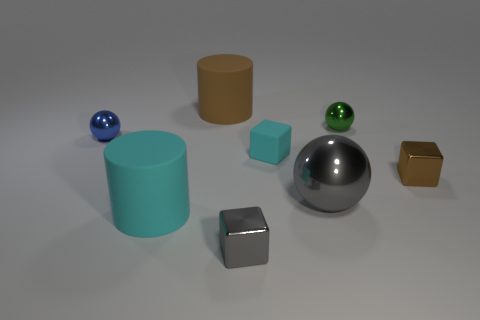What number of brown objects have the same size as the gray metallic sphere?
Your answer should be very brief. 1. What shape is the rubber object in front of the brown object in front of the tiny matte cube?
Give a very brief answer. Cylinder. There is a rubber object that is in front of the brown thing in front of the large matte cylinder behind the tiny green metallic object; what is its shape?
Ensure brevity in your answer.  Cylinder. What number of small metallic objects are the same shape as the big cyan thing?
Provide a succinct answer. 0. There is a metal cube right of the green object; how many brown objects are behind it?
Provide a short and direct response. 1. What number of metal things are large purple spheres or brown cylinders?
Your answer should be compact. 0. Are there any tiny balls that have the same material as the brown cube?
Give a very brief answer. Yes. What number of objects are either small metal spheres left of the small cyan matte object or brown objects that are to the left of the big gray object?
Make the answer very short. 2. Is the color of the small metal block left of the tiny green metal sphere the same as the big sphere?
Offer a very short reply. Yes. What number of other objects are the same color as the rubber cube?
Provide a succinct answer. 1. 